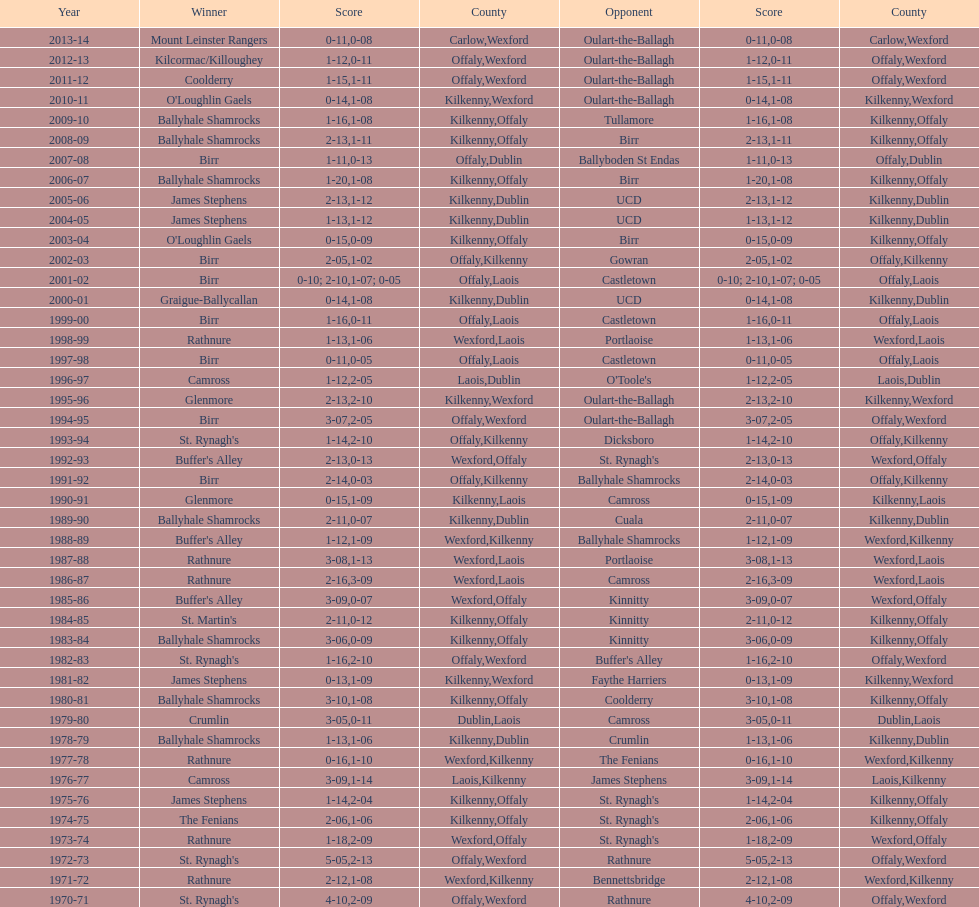Would you be able to parse every entry in this table? {'header': ['Year', 'Winner', 'Score', 'County', 'Opponent', 'Score', 'County'], 'rows': [['2013-14', 'Mount Leinster Rangers', '0-11', 'Carlow', 'Oulart-the-Ballagh', '0-08', 'Wexford'], ['2012-13', 'Kilcormac/Killoughey', '1-12', 'Offaly', 'Oulart-the-Ballagh', '0-11', 'Wexford'], ['2011-12', 'Coolderry', '1-15', 'Offaly', 'Oulart-the-Ballagh', '1-11', 'Wexford'], ['2010-11', "O'Loughlin Gaels", '0-14', 'Kilkenny', 'Oulart-the-Ballagh', '1-08', 'Wexford'], ['2009-10', 'Ballyhale Shamrocks', '1-16', 'Kilkenny', 'Tullamore', '1-08', 'Offaly'], ['2008-09', 'Ballyhale Shamrocks', '2-13', 'Kilkenny', 'Birr', '1-11', 'Offaly'], ['2007-08', 'Birr', '1-11', 'Offaly', 'Ballyboden St Endas', '0-13', 'Dublin'], ['2006-07', 'Ballyhale Shamrocks', '1-20', 'Kilkenny', 'Birr', '1-08', 'Offaly'], ['2005-06', 'James Stephens', '2-13', 'Kilkenny', 'UCD', '1-12', 'Dublin'], ['2004-05', 'James Stephens', '1-13', 'Kilkenny', 'UCD', '1-12', 'Dublin'], ['2003-04', "O'Loughlin Gaels", '0-15', 'Kilkenny', 'Birr', '0-09', 'Offaly'], ['2002-03', 'Birr', '2-05', 'Offaly', 'Gowran', '1-02', 'Kilkenny'], ['2001-02', 'Birr', '0-10; 2-10', 'Offaly', 'Castletown', '1-07; 0-05', 'Laois'], ['2000-01', 'Graigue-Ballycallan', '0-14', 'Kilkenny', 'UCD', '1-08', 'Dublin'], ['1999-00', 'Birr', '1-16', 'Offaly', 'Castletown', '0-11', 'Laois'], ['1998-99', 'Rathnure', '1-13', 'Wexford', 'Portlaoise', '1-06', 'Laois'], ['1997-98', 'Birr', '0-11', 'Offaly', 'Castletown', '0-05', 'Laois'], ['1996-97', 'Camross', '1-12', 'Laois', "O'Toole's", '2-05', 'Dublin'], ['1995-96', 'Glenmore', '2-13', 'Kilkenny', 'Oulart-the-Ballagh', '2-10', 'Wexford'], ['1994-95', 'Birr', '3-07', 'Offaly', 'Oulart-the-Ballagh', '2-05', 'Wexford'], ['1993-94', "St. Rynagh's", '1-14', 'Offaly', 'Dicksboro', '2-10', 'Kilkenny'], ['1992-93', "Buffer's Alley", '2-13', 'Wexford', "St. Rynagh's", '0-13', 'Offaly'], ['1991-92', 'Birr', '2-14', 'Offaly', 'Ballyhale Shamrocks', '0-03', 'Kilkenny'], ['1990-91', 'Glenmore', '0-15', 'Kilkenny', 'Camross', '1-09', 'Laois'], ['1989-90', 'Ballyhale Shamrocks', '2-11', 'Kilkenny', 'Cuala', '0-07', 'Dublin'], ['1988-89', "Buffer's Alley", '1-12', 'Wexford', 'Ballyhale Shamrocks', '1-09', 'Kilkenny'], ['1987-88', 'Rathnure', '3-08', 'Wexford', 'Portlaoise', '1-13', 'Laois'], ['1986-87', 'Rathnure', '2-16', 'Wexford', 'Camross', '3-09', 'Laois'], ['1985-86', "Buffer's Alley", '3-09', 'Wexford', 'Kinnitty', '0-07', 'Offaly'], ['1984-85', "St. Martin's", '2-11', 'Kilkenny', 'Kinnitty', '0-12', 'Offaly'], ['1983-84', 'Ballyhale Shamrocks', '3-06', 'Kilkenny', 'Kinnitty', '0-09', 'Offaly'], ['1982-83', "St. Rynagh's", '1-16', 'Offaly', "Buffer's Alley", '2-10', 'Wexford'], ['1981-82', 'James Stephens', '0-13', 'Kilkenny', 'Faythe Harriers', '1-09', 'Wexford'], ['1980-81', 'Ballyhale Shamrocks', '3-10', 'Kilkenny', 'Coolderry', '1-08', 'Offaly'], ['1979-80', 'Crumlin', '3-05', 'Dublin', 'Camross', '0-11', 'Laois'], ['1978-79', 'Ballyhale Shamrocks', '1-13', 'Kilkenny', 'Crumlin', '1-06', 'Dublin'], ['1977-78', 'Rathnure', '0-16', 'Wexford', 'The Fenians', '1-10', 'Kilkenny'], ['1976-77', 'Camross', '3-09', 'Laois', 'James Stephens', '1-14', 'Kilkenny'], ['1975-76', 'James Stephens', '1-14', 'Kilkenny', "St. Rynagh's", '2-04', 'Offaly'], ['1974-75', 'The Fenians', '2-06', 'Kilkenny', "St. Rynagh's", '1-06', 'Offaly'], ['1973-74', 'Rathnure', '1-18', 'Wexford', "St. Rynagh's", '2-09', 'Offaly'], ['1972-73', "St. Rynagh's", '5-05', 'Offaly', 'Rathnure', '2-13', 'Wexford'], ['1971-72', 'Rathnure', '2-12', 'Wexford', 'Bennettsbridge', '1-08', 'Kilkenny'], ['1970-71', "St. Rynagh's", '4-10', 'Offaly', 'Rathnure', '2-09', 'Wexford']]} Over how many years in a row did rathnure secure wins? 2. 